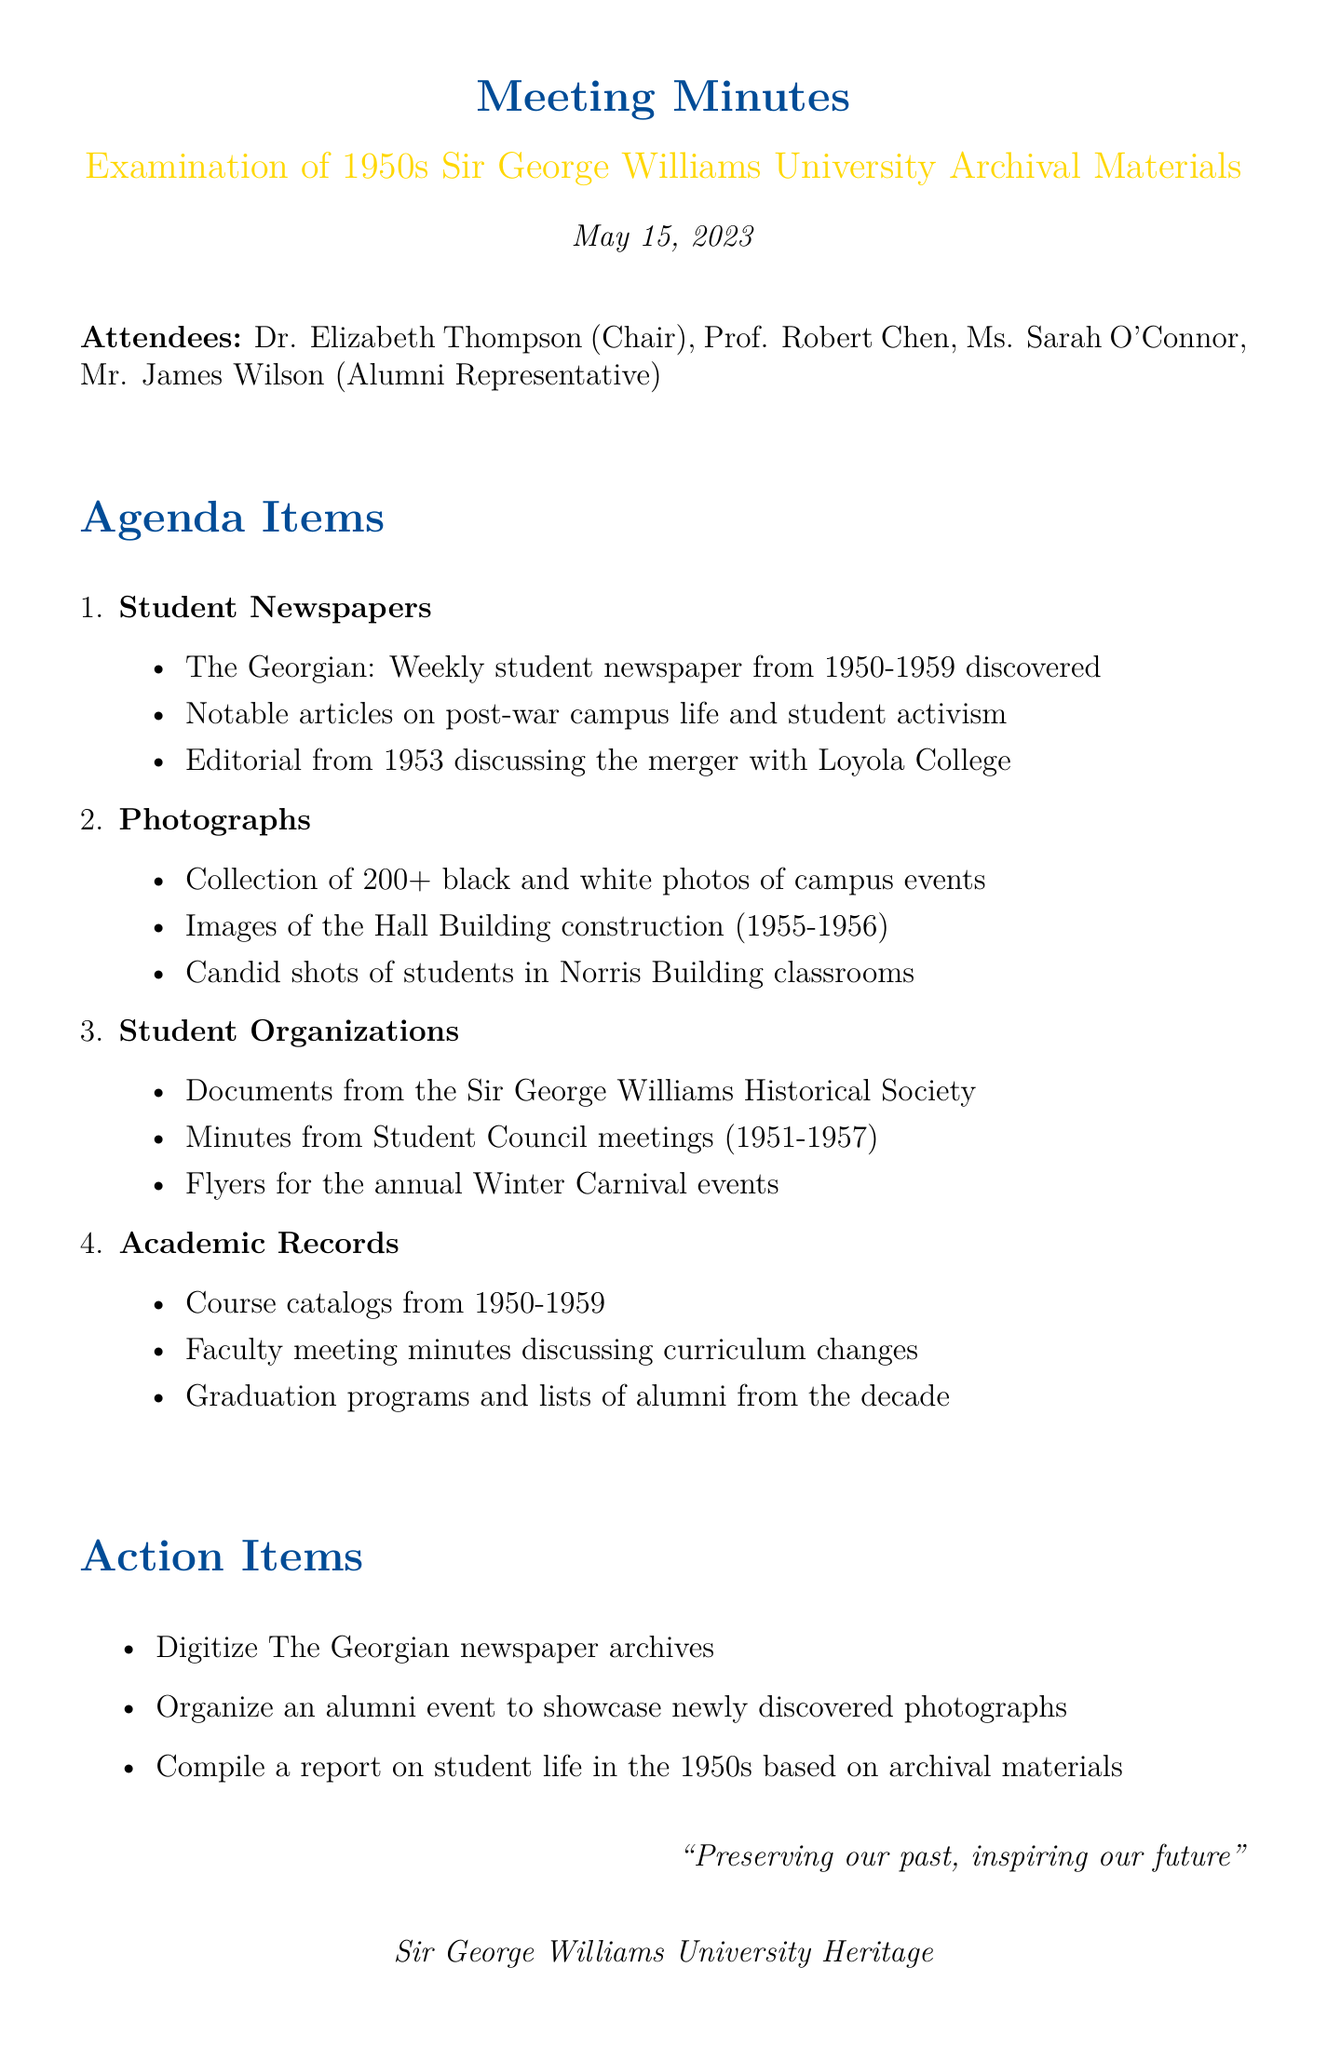What is the date of the meeting? The date of the meeting is explicitly stated in the document.
Answer: May 15, 2023 Who chaired the meeting? The document lists Dr. Elizabeth Thompson as the Chair of the meeting.
Answer: Dr. Elizabeth Thompson What is the name of the weekly student newspaper from 1950 to 1959? The document mentions the name of the student newspaper under the agenda item for Student Newspapers.
Answer: The Georgian How many black and white photographs were collected? The document specifies the number of photographs collected under the Photographs section.
Answer: 200+ What years do the course catalogs cover? The document provides a specific time range for the course catalogs within the Academic Records section.
Answer: 1950-1959 What type of documents were found from the Sir George Williams Historical Society? The document mentions specific collections under the Student Organizations agenda item.
Answer: Documents What action item involves showcasing photographs? The document lists an action item related to organizing an event.
Answer: Organize an alumni event How many years do the Student Council meeting minutes cover? The document specifies the years during which the Student Council meetings were recorded.
Answer: 1951-1957 What notable topic was discussed in the 1953 editorial? The document refers to the subject of the editorial under the Student Newspapers section.
Answer: Merger with Loyola College 